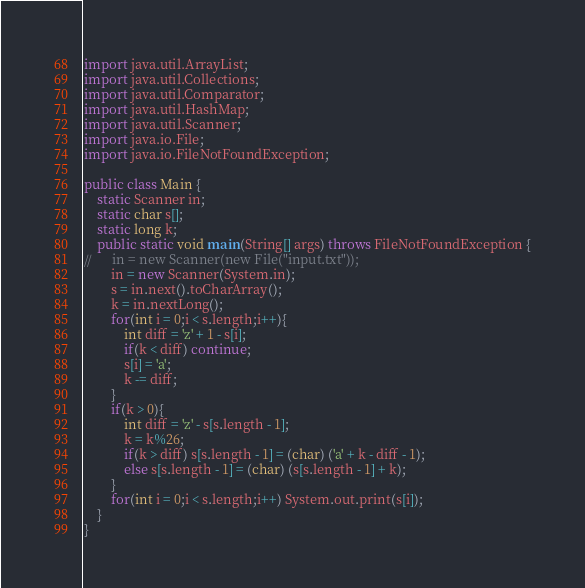<code> <loc_0><loc_0><loc_500><loc_500><_Java_>import java.util.ArrayList;
import java.util.Collections;
import java.util.Comparator;
import java.util.HashMap;
import java.util.Scanner;
import java.io.File;
import java.io.FileNotFoundException;
 
public class Main {
	static Scanner in;
	static char s[];
	static long k;
	public static void main(String[] args) throws FileNotFoundException {
//		in = new Scanner(new File("input.txt"));
		in = new Scanner(System.in);
		s = in.next().toCharArray();
		k = in.nextLong();
		for(int i = 0;i < s.length;i++){
			int diff = 'z' + 1 - s[i];
			if(k < diff) continue;
			s[i] = 'a';
			k -= diff;
		}
		if(k > 0){
			int diff = 'z' - s[s.length - 1];
			k = k%26;
			if(k > diff) s[s.length - 1] = (char) ('a' + k - diff - 1);
			else s[s.length - 1] = (char) (s[s.length - 1] + k);
		}
		for(int i = 0;i < s.length;i++) System.out.print(s[i]);
	}
}</code> 